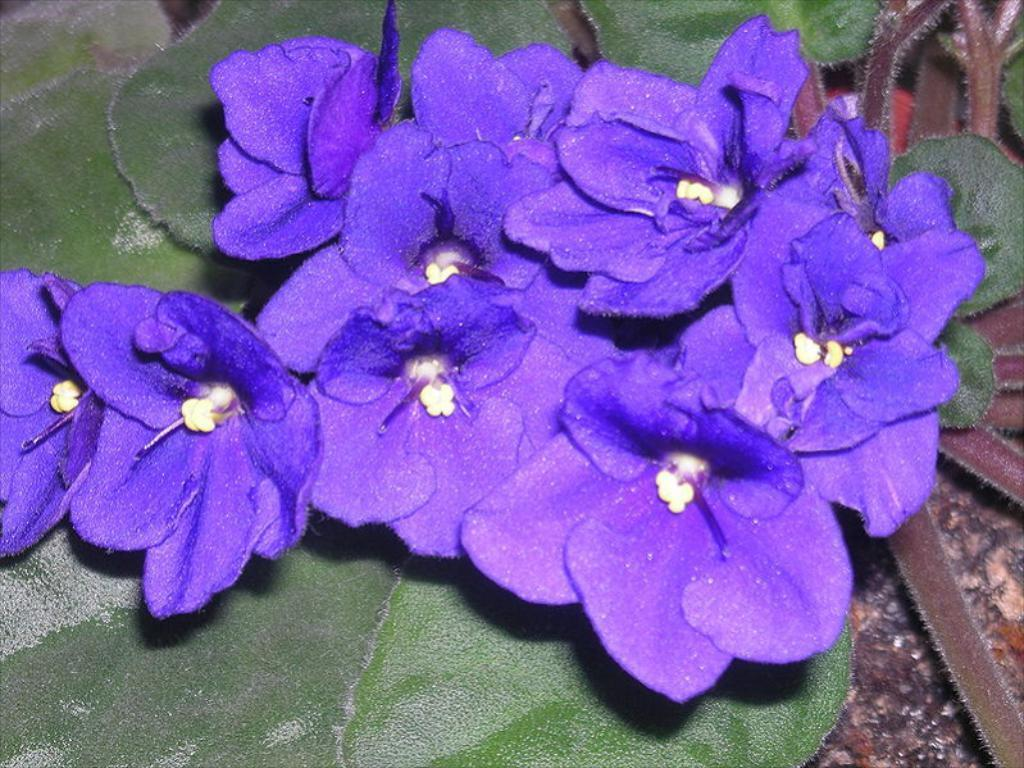What type of living organisms can be seen in the image? Plants and flowers can be seen in the image. Can you describe the ground visible in the image? The ground is visible in the image. What type of needle can be seen in the image? There is no needle present in the image. 